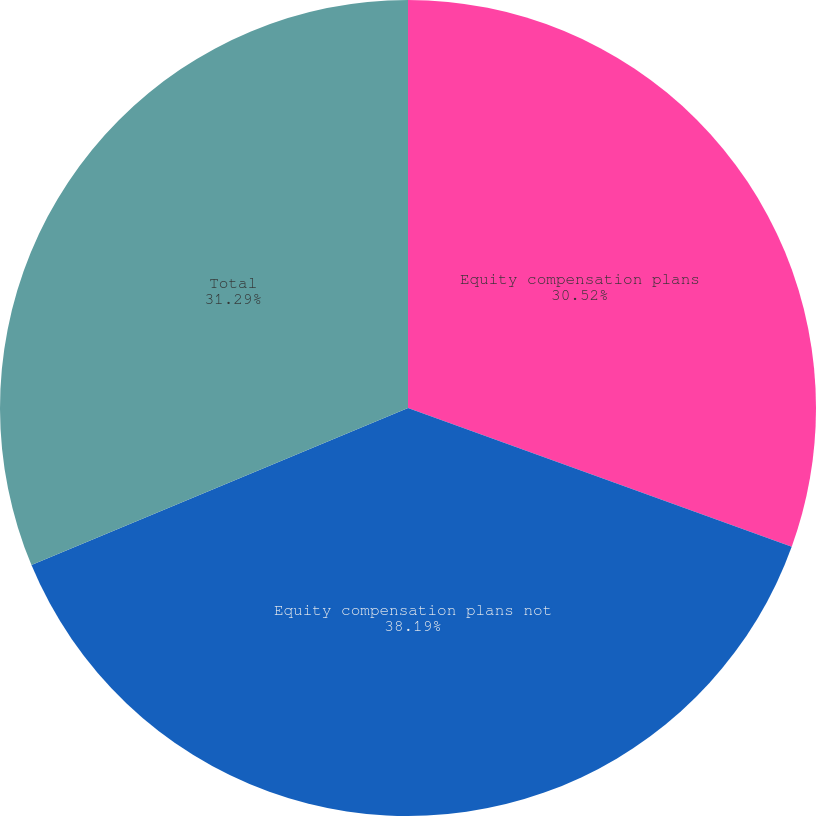Convert chart to OTSL. <chart><loc_0><loc_0><loc_500><loc_500><pie_chart><fcel>Equity compensation plans<fcel>Equity compensation plans not<fcel>Total<nl><fcel>30.52%<fcel>38.19%<fcel>31.29%<nl></chart> 